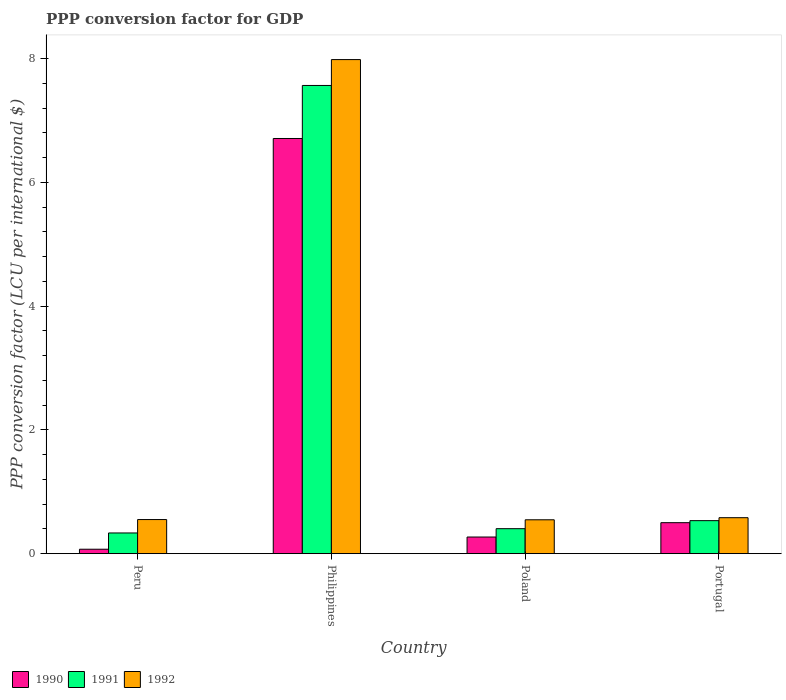How many different coloured bars are there?
Provide a short and direct response. 3. Are the number of bars on each tick of the X-axis equal?
Keep it short and to the point. Yes. How many bars are there on the 4th tick from the left?
Your answer should be compact. 3. In how many cases, is the number of bars for a given country not equal to the number of legend labels?
Your response must be concise. 0. What is the PPP conversion factor for GDP in 1992 in Portugal?
Provide a succinct answer. 0.58. Across all countries, what is the maximum PPP conversion factor for GDP in 1990?
Your response must be concise. 6.71. Across all countries, what is the minimum PPP conversion factor for GDP in 1992?
Keep it short and to the point. 0.55. In which country was the PPP conversion factor for GDP in 1992 maximum?
Provide a short and direct response. Philippines. What is the total PPP conversion factor for GDP in 1990 in the graph?
Your answer should be very brief. 7.55. What is the difference between the PPP conversion factor for GDP in 1991 in Peru and that in Portugal?
Your response must be concise. -0.2. What is the difference between the PPP conversion factor for GDP in 1990 in Philippines and the PPP conversion factor for GDP in 1992 in Poland?
Ensure brevity in your answer.  6.16. What is the average PPP conversion factor for GDP in 1991 per country?
Your answer should be very brief. 2.21. What is the difference between the PPP conversion factor for GDP of/in 1991 and PPP conversion factor for GDP of/in 1992 in Philippines?
Ensure brevity in your answer.  -0.42. What is the ratio of the PPP conversion factor for GDP in 1991 in Peru to that in Philippines?
Keep it short and to the point. 0.04. What is the difference between the highest and the second highest PPP conversion factor for GDP in 1992?
Your response must be concise. 0.03. What is the difference between the highest and the lowest PPP conversion factor for GDP in 1991?
Keep it short and to the point. 7.23. Is the sum of the PPP conversion factor for GDP in 1990 in Poland and Portugal greater than the maximum PPP conversion factor for GDP in 1992 across all countries?
Ensure brevity in your answer.  No. What does the 3rd bar from the right in Portugal represents?
Keep it short and to the point. 1990. How many bars are there?
Provide a short and direct response. 12. How are the legend labels stacked?
Make the answer very short. Horizontal. What is the title of the graph?
Provide a succinct answer. PPP conversion factor for GDP. What is the label or title of the Y-axis?
Offer a very short reply. PPP conversion factor (LCU per international $). What is the PPP conversion factor (LCU per international $) in 1990 in Peru?
Offer a terse response. 0.07. What is the PPP conversion factor (LCU per international $) of 1991 in Peru?
Your answer should be very brief. 0.33. What is the PPP conversion factor (LCU per international $) in 1992 in Peru?
Offer a terse response. 0.55. What is the PPP conversion factor (LCU per international $) in 1990 in Philippines?
Make the answer very short. 6.71. What is the PPP conversion factor (LCU per international $) of 1991 in Philippines?
Your response must be concise. 7.57. What is the PPP conversion factor (LCU per international $) of 1992 in Philippines?
Give a very brief answer. 7.98. What is the PPP conversion factor (LCU per international $) of 1990 in Poland?
Make the answer very short. 0.27. What is the PPP conversion factor (LCU per international $) in 1991 in Poland?
Keep it short and to the point. 0.4. What is the PPP conversion factor (LCU per international $) of 1992 in Poland?
Offer a very short reply. 0.55. What is the PPP conversion factor (LCU per international $) of 1990 in Portugal?
Offer a terse response. 0.5. What is the PPP conversion factor (LCU per international $) of 1991 in Portugal?
Offer a terse response. 0.53. What is the PPP conversion factor (LCU per international $) in 1992 in Portugal?
Offer a terse response. 0.58. Across all countries, what is the maximum PPP conversion factor (LCU per international $) in 1990?
Make the answer very short. 6.71. Across all countries, what is the maximum PPP conversion factor (LCU per international $) in 1991?
Ensure brevity in your answer.  7.57. Across all countries, what is the maximum PPP conversion factor (LCU per international $) in 1992?
Your answer should be compact. 7.98. Across all countries, what is the minimum PPP conversion factor (LCU per international $) in 1990?
Offer a very short reply. 0.07. Across all countries, what is the minimum PPP conversion factor (LCU per international $) in 1991?
Keep it short and to the point. 0.33. Across all countries, what is the minimum PPP conversion factor (LCU per international $) of 1992?
Your response must be concise. 0.55. What is the total PPP conversion factor (LCU per international $) of 1990 in the graph?
Your answer should be compact. 7.55. What is the total PPP conversion factor (LCU per international $) of 1991 in the graph?
Your answer should be very brief. 8.84. What is the total PPP conversion factor (LCU per international $) of 1992 in the graph?
Offer a very short reply. 9.66. What is the difference between the PPP conversion factor (LCU per international $) in 1990 in Peru and that in Philippines?
Provide a succinct answer. -6.64. What is the difference between the PPP conversion factor (LCU per international $) of 1991 in Peru and that in Philippines?
Ensure brevity in your answer.  -7.23. What is the difference between the PPP conversion factor (LCU per international $) of 1992 in Peru and that in Philippines?
Your answer should be compact. -7.43. What is the difference between the PPP conversion factor (LCU per international $) of 1990 in Peru and that in Poland?
Keep it short and to the point. -0.2. What is the difference between the PPP conversion factor (LCU per international $) of 1991 in Peru and that in Poland?
Keep it short and to the point. -0.07. What is the difference between the PPP conversion factor (LCU per international $) in 1992 in Peru and that in Poland?
Provide a succinct answer. 0. What is the difference between the PPP conversion factor (LCU per international $) of 1990 in Peru and that in Portugal?
Provide a short and direct response. -0.43. What is the difference between the PPP conversion factor (LCU per international $) in 1991 in Peru and that in Portugal?
Give a very brief answer. -0.2. What is the difference between the PPP conversion factor (LCU per international $) of 1992 in Peru and that in Portugal?
Offer a terse response. -0.03. What is the difference between the PPP conversion factor (LCU per international $) of 1990 in Philippines and that in Poland?
Give a very brief answer. 6.44. What is the difference between the PPP conversion factor (LCU per international $) of 1991 in Philippines and that in Poland?
Provide a short and direct response. 7.16. What is the difference between the PPP conversion factor (LCU per international $) of 1992 in Philippines and that in Poland?
Provide a succinct answer. 7.44. What is the difference between the PPP conversion factor (LCU per international $) in 1990 in Philippines and that in Portugal?
Provide a succinct answer. 6.21. What is the difference between the PPP conversion factor (LCU per international $) of 1991 in Philippines and that in Portugal?
Make the answer very short. 7.03. What is the difference between the PPP conversion factor (LCU per international $) of 1992 in Philippines and that in Portugal?
Make the answer very short. 7.4. What is the difference between the PPP conversion factor (LCU per international $) in 1990 in Poland and that in Portugal?
Ensure brevity in your answer.  -0.23. What is the difference between the PPP conversion factor (LCU per international $) of 1991 in Poland and that in Portugal?
Offer a terse response. -0.13. What is the difference between the PPP conversion factor (LCU per international $) in 1992 in Poland and that in Portugal?
Provide a succinct answer. -0.03. What is the difference between the PPP conversion factor (LCU per international $) of 1990 in Peru and the PPP conversion factor (LCU per international $) of 1991 in Philippines?
Provide a short and direct response. -7.49. What is the difference between the PPP conversion factor (LCU per international $) of 1990 in Peru and the PPP conversion factor (LCU per international $) of 1992 in Philippines?
Offer a very short reply. -7.91. What is the difference between the PPP conversion factor (LCU per international $) of 1991 in Peru and the PPP conversion factor (LCU per international $) of 1992 in Philippines?
Make the answer very short. -7.65. What is the difference between the PPP conversion factor (LCU per international $) in 1990 in Peru and the PPP conversion factor (LCU per international $) in 1991 in Poland?
Ensure brevity in your answer.  -0.33. What is the difference between the PPP conversion factor (LCU per international $) in 1990 in Peru and the PPP conversion factor (LCU per international $) in 1992 in Poland?
Give a very brief answer. -0.48. What is the difference between the PPP conversion factor (LCU per international $) in 1991 in Peru and the PPP conversion factor (LCU per international $) in 1992 in Poland?
Provide a succinct answer. -0.21. What is the difference between the PPP conversion factor (LCU per international $) in 1990 in Peru and the PPP conversion factor (LCU per international $) in 1991 in Portugal?
Ensure brevity in your answer.  -0.46. What is the difference between the PPP conversion factor (LCU per international $) of 1990 in Peru and the PPP conversion factor (LCU per international $) of 1992 in Portugal?
Provide a succinct answer. -0.51. What is the difference between the PPP conversion factor (LCU per international $) of 1991 in Peru and the PPP conversion factor (LCU per international $) of 1992 in Portugal?
Your answer should be very brief. -0.25. What is the difference between the PPP conversion factor (LCU per international $) in 1990 in Philippines and the PPP conversion factor (LCU per international $) in 1991 in Poland?
Your answer should be very brief. 6.31. What is the difference between the PPP conversion factor (LCU per international $) in 1990 in Philippines and the PPP conversion factor (LCU per international $) in 1992 in Poland?
Provide a succinct answer. 6.16. What is the difference between the PPP conversion factor (LCU per international $) in 1991 in Philippines and the PPP conversion factor (LCU per international $) in 1992 in Poland?
Ensure brevity in your answer.  7.02. What is the difference between the PPP conversion factor (LCU per international $) of 1990 in Philippines and the PPP conversion factor (LCU per international $) of 1991 in Portugal?
Your answer should be very brief. 6.18. What is the difference between the PPP conversion factor (LCU per international $) of 1990 in Philippines and the PPP conversion factor (LCU per international $) of 1992 in Portugal?
Your answer should be very brief. 6.13. What is the difference between the PPP conversion factor (LCU per international $) in 1991 in Philippines and the PPP conversion factor (LCU per international $) in 1992 in Portugal?
Make the answer very short. 6.98. What is the difference between the PPP conversion factor (LCU per international $) in 1990 in Poland and the PPP conversion factor (LCU per international $) in 1991 in Portugal?
Give a very brief answer. -0.26. What is the difference between the PPP conversion factor (LCU per international $) of 1990 in Poland and the PPP conversion factor (LCU per international $) of 1992 in Portugal?
Give a very brief answer. -0.31. What is the difference between the PPP conversion factor (LCU per international $) in 1991 in Poland and the PPP conversion factor (LCU per international $) in 1992 in Portugal?
Your response must be concise. -0.18. What is the average PPP conversion factor (LCU per international $) of 1990 per country?
Offer a very short reply. 1.89. What is the average PPP conversion factor (LCU per international $) of 1991 per country?
Provide a succinct answer. 2.21. What is the average PPP conversion factor (LCU per international $) in 1992 per country?
Keep it short and to the point. 2.42. What is the difference between the PPP conversion factor (LCU per international $) in 1990 and PPP conversion factor (LCU per international $) in 1991 in Peru?
Make the answer very short. -0.26. What is the difference between the PPP conversion factor (LCU per international $) of 1990 and PPP conversion factor (LCU per international $) of 1992 in Peru?
Ensure brevity in your answer.  -0.48. What is the difference between the PPP conversion factor (LCU per international $) in 1991 and PPP conversion factor (LCU per international $) in 1992 in Peru?
Ensure brevity in your answer.  -0.22. What is the difference between the PPP conversion factor (LCU per international $) in 1990 and PPP conversion factor (LCU per international $) in 1991 in Philippines?
Your response must be concise. -0.86. What is the difference between the PPP conversion factor (LCU per international $) of 1990 and PPP conversion factor (LCU per international $) of 1992 in Philippines?
Provide a succinct answer. -1.28. What is the difference between the PPP conversion factor (LCU per international $) of 1991 and PPP conversion factor (LCU per international $) of 1992 in Philippines?
Give a very brief answer. -0.42. What is the difference between the PPP conversion factor (LCU per international $) of 1990 and PPP conversion factor (LCU per international $) of 1991 in Poland?
Ensure brevity in your answer.  -0.14. What is the difference between the PPP conversion factor (LCU per international $) of 1990 and PPP conversion factor (LCU per international $) of 1992 in Poland?
Ensure brevity in your answer.  -0.28. What is the difference between the PPP conversion factor (LCU per international $) of 1991 and PPP conversion factor (LCU per international $) of 1992 in Poland?
Your response must be concise. -0.14. What is the difference between the PPP conversion factor (LCU per international $) of 1990 and PPP conversion factor (LCU per international $) of 1991 in Portugal?
Offer a very short reply. -0.03. What is the difference between the PPP conversion factor (LCU per international $) of 1990 and PPP conversion factor (LCU per international $) of 1992 in Portugal?
Provide a short and direct response. -0.08. What is the difference between the PPP conversion factor (LCU per international $) of 1991 and PPP conversion factor (LCU per international $) of 1992 in Portugal?
Keep it short and to the point. -0.05. What is the ratio of the PPP conversion factor (LCU per international $) in 1990 in Peru to that in Philippines?
Offer a terse response. 0.01. What is the ratio of the PPP conversion factor (LCU per international $) of 1991 in Peru to that in Philippines?
Make the answer very short. 0.04. What is the ratio of the PPP conversion factor (LCU per international $) of 1992 in Peru to that in Philippines?
Make the answer very short. 0.07. What is the ratio of the PPP conversion factor (LCU per international $) in 1990 in Peru to that in Poland?
Your response must be concise. 0.27. What is the ratio of the PPP conversion factor (LCU per international $) in 1991 in Peru to that in Poland?
Your answer should be compact. 0.83. What is the ratio of the PPP conversion factor (LCU per international $) of 1992 in Peru to that in Poland?
Keep it short and to the point. 1.01. What is the ratio of the PPP conversion factor (LCU per international $) of 1990 in Peru to that in Portugal?
Offer a terse response. 0.14. What is the ratio of the PPP conversion factor (LCU per international $) in 1991 in Peru to that in Portugal?
Offer a very short reply. 0.63. What is the ratio of the PPP conversion factor (LCU per international $) of 1992 in Peru to that in Portugal?
Offer a terse response. 0.95. What is the ratio of the PPP conversion factor (LCU per international $) of 1990 in Philippines to that in Poland?
Ensure brevity in your answer.  24.97. What is the ratio of the PPP conversion factor (LCU per international $) of 1991 in Philippines to that in Poland?
Keep it short and to the point. 18.74. What is the ratio of the PPP conversion factor (LCU per international $) in 1992 in Philippines to that in Poland?
Provide a succinct answer. 14.59. What is the ratio of the PPP conversion factor (LCU per international $) in 1990 in Philippines to that in Portugal?
Give a very brief answer. 13.4. What is the ratio of the PPP conversion factor (LCU per international $) of 1991 in Philippines to that in Portugal?
Keep it short and to the point. 14.18. What is the ratio of the PPP conversion factor (LCU per international $) of 1992 in Philippines to that in Portugal?
Keep it short and to the point. 13.74. What is the ratio of the PPP conversion factor (LCU per international $) of 1990 in Poland to that in Portugal?
Your response must be concise. 0.54. What is the ratio of the PPP conversion factor (LCU per international $) of 1991 in Poland to that in Portugal?
Offer a terse response. 0.76. What is the ratio of the PPP conversion factor (LCU per international $) in 1992 in Poland to that in Portugal?
Ensure brevity in your answer.  0.94. What is the difference between the highest and the second highest PPP conversion factor (LCU per international $) in 1990?
Ensure brevity in your answer.  6.21. What is the difference between the highest and the second highest PPP conversion factor (LCU per international $) in 1991?
Your answer should be very brief. 7.03. What is the difference between the highest and the second highest PPP conversion factor (LCU per international $) of 1992?
Make the answer very short. 7.4. What is the difference between the highest and the lowest PPP conversion factor (LCU per international $) of 1990?
Give a very brief answer. 6.64. What is the difference between the highest and the lowest PPP conversion factor (LCU per international $) in 1991?
Your answer should be very brief. 7.23. What is the difference between the highest and the lowest PPP conversion factor (LCU per international $) of 1992?
Provide a short and direct response. 7.44. 